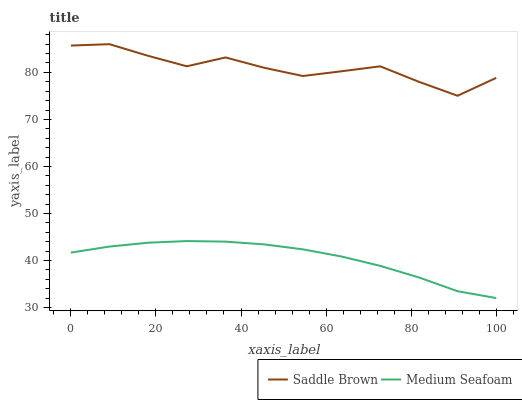Does Medium Seafoam have the minimum area under the curve?
Answer yes or no. Yes. Does Saddle Brown have the maximum area under the curve?
Answer yes or no. Yes. Does Medium Seafoam have the maximum area under the curve?
Answer yes or no. No. Is Medium Seafoam the smoothest?
Answer yes or no. Yes. Is Saddle Brown the roughest?
Answer yes or no. Yes. Is Medium Seafoam the roughest?
Answer yes or no. No. Does Medium Seafoam have the lowest value?
Answer yes or no. Yes. Does Saddle Brown have the highest value?
Answer yes or no. Yes. Does Medium Seafoam have the highest value?
Answer yes or no. No. Is Medium Seafoam less than Saddle Brown?
Answer yes or no. Yes. Is Saddle Brown greater than Medium Seafoam?
Answer yes or no. Yes. Does Medium Seafoam intersect Saddle Brown?
Answer yes or no. No. 